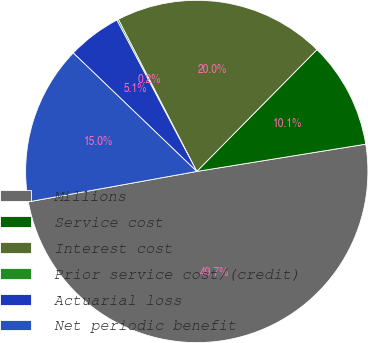Convert chart. <chart><loc_0><loc_0><loc_500><loc_500><pie_chart><fcel>Millions<fcel>Service cost<fcel>Interest cost<fcel>Prior service cost/(credit)<fcel>Actuarial loss<fcel>Net periodic benefit<nl><fcel>49.7%<fcel>10.06%<fcel>19.97%<fcel>0.15%<fcel>5.1%<fcel>15.01%<nl></chart> 